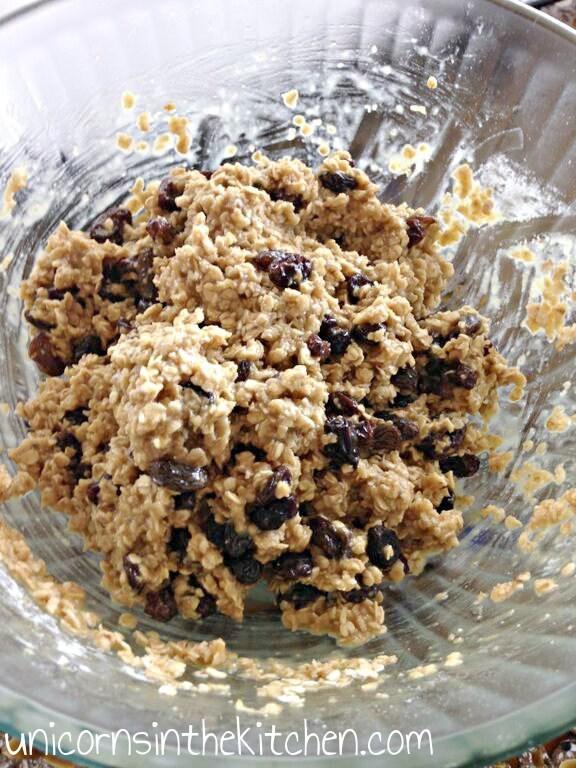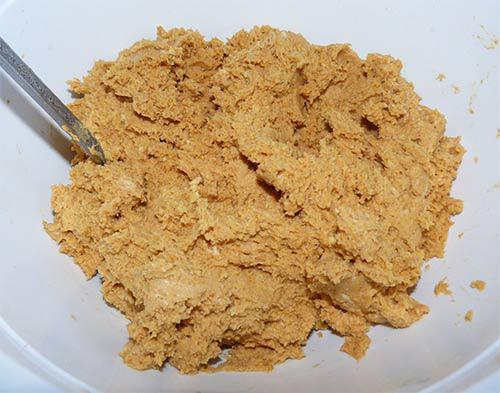The first image is the image on the left, the second image is the image on the right. Considering the images on both sides, is "Some of the cookie dough is in balls neatly lined up." valid? Answer yes or no. No. 